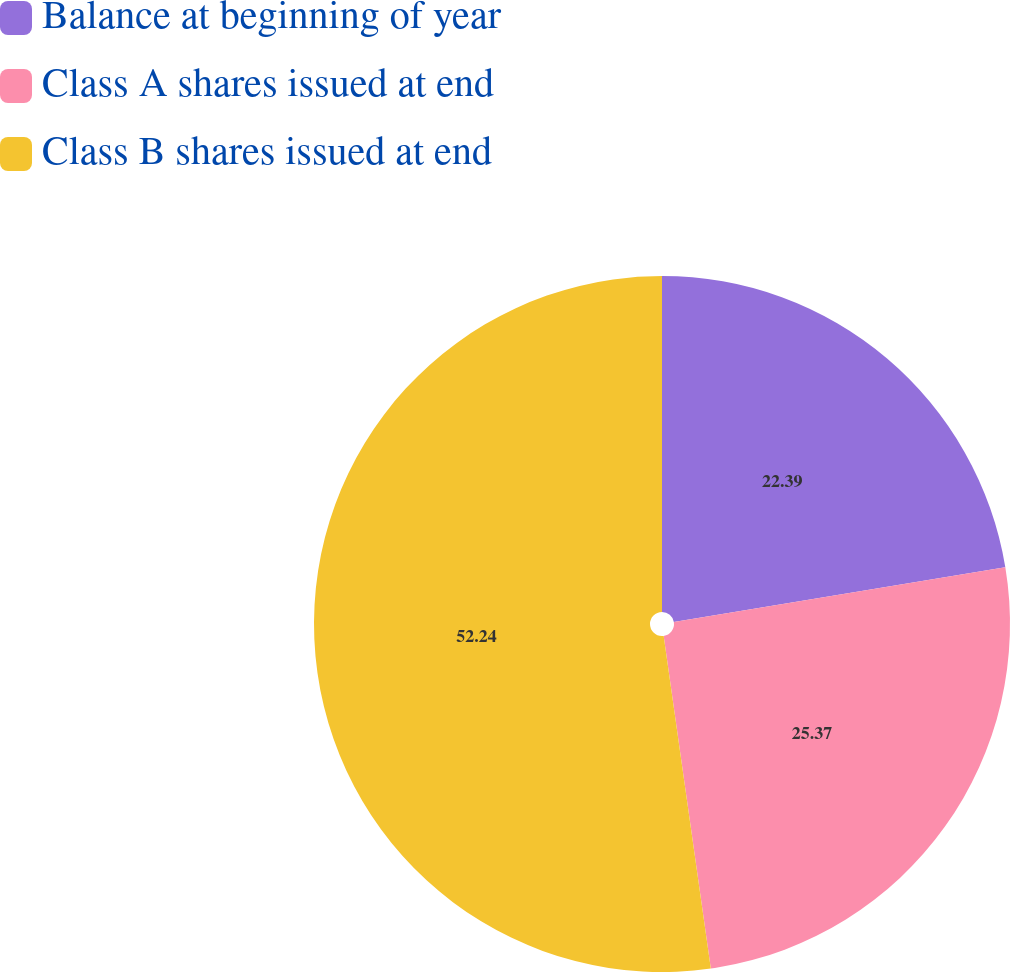Convert chart to OTSL. <chart><loc_0><loc_0><loc_500><loc_500><pie_chart><fcel>Balance at beginning of year<fcel>Class A shares issued at end<fcel>Class B shares issued at end<nl><fcel>22.39%<fcel>25.37%<fcel>52.24%<nl></chart> 